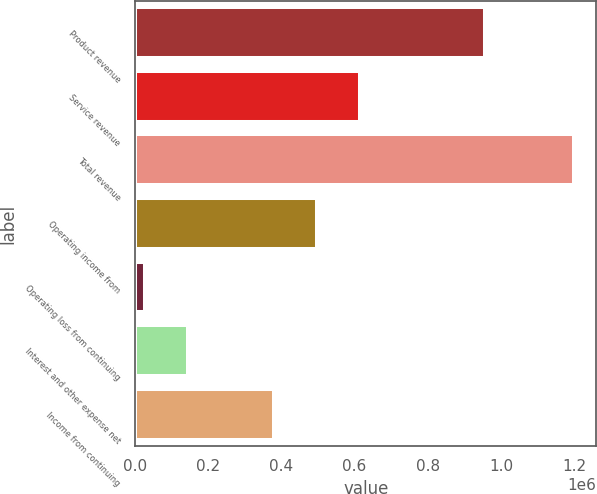<chart> <loc_0><loc_0><loc_500><loc_500><bar_chart><fcel>Product revenue<fcel>Service revenue<fcel>Total revenue<fcel>Operating income from<fcel>Operating loss from continuing<fcel>Interest and other expense net<fcel>Income from continuing<nl><fcel>957022<fcel>613410<fcel>1.20111e+06<fcel>495870<fcel>25710<fcel>143250<fcel>378330<nl></chart> 